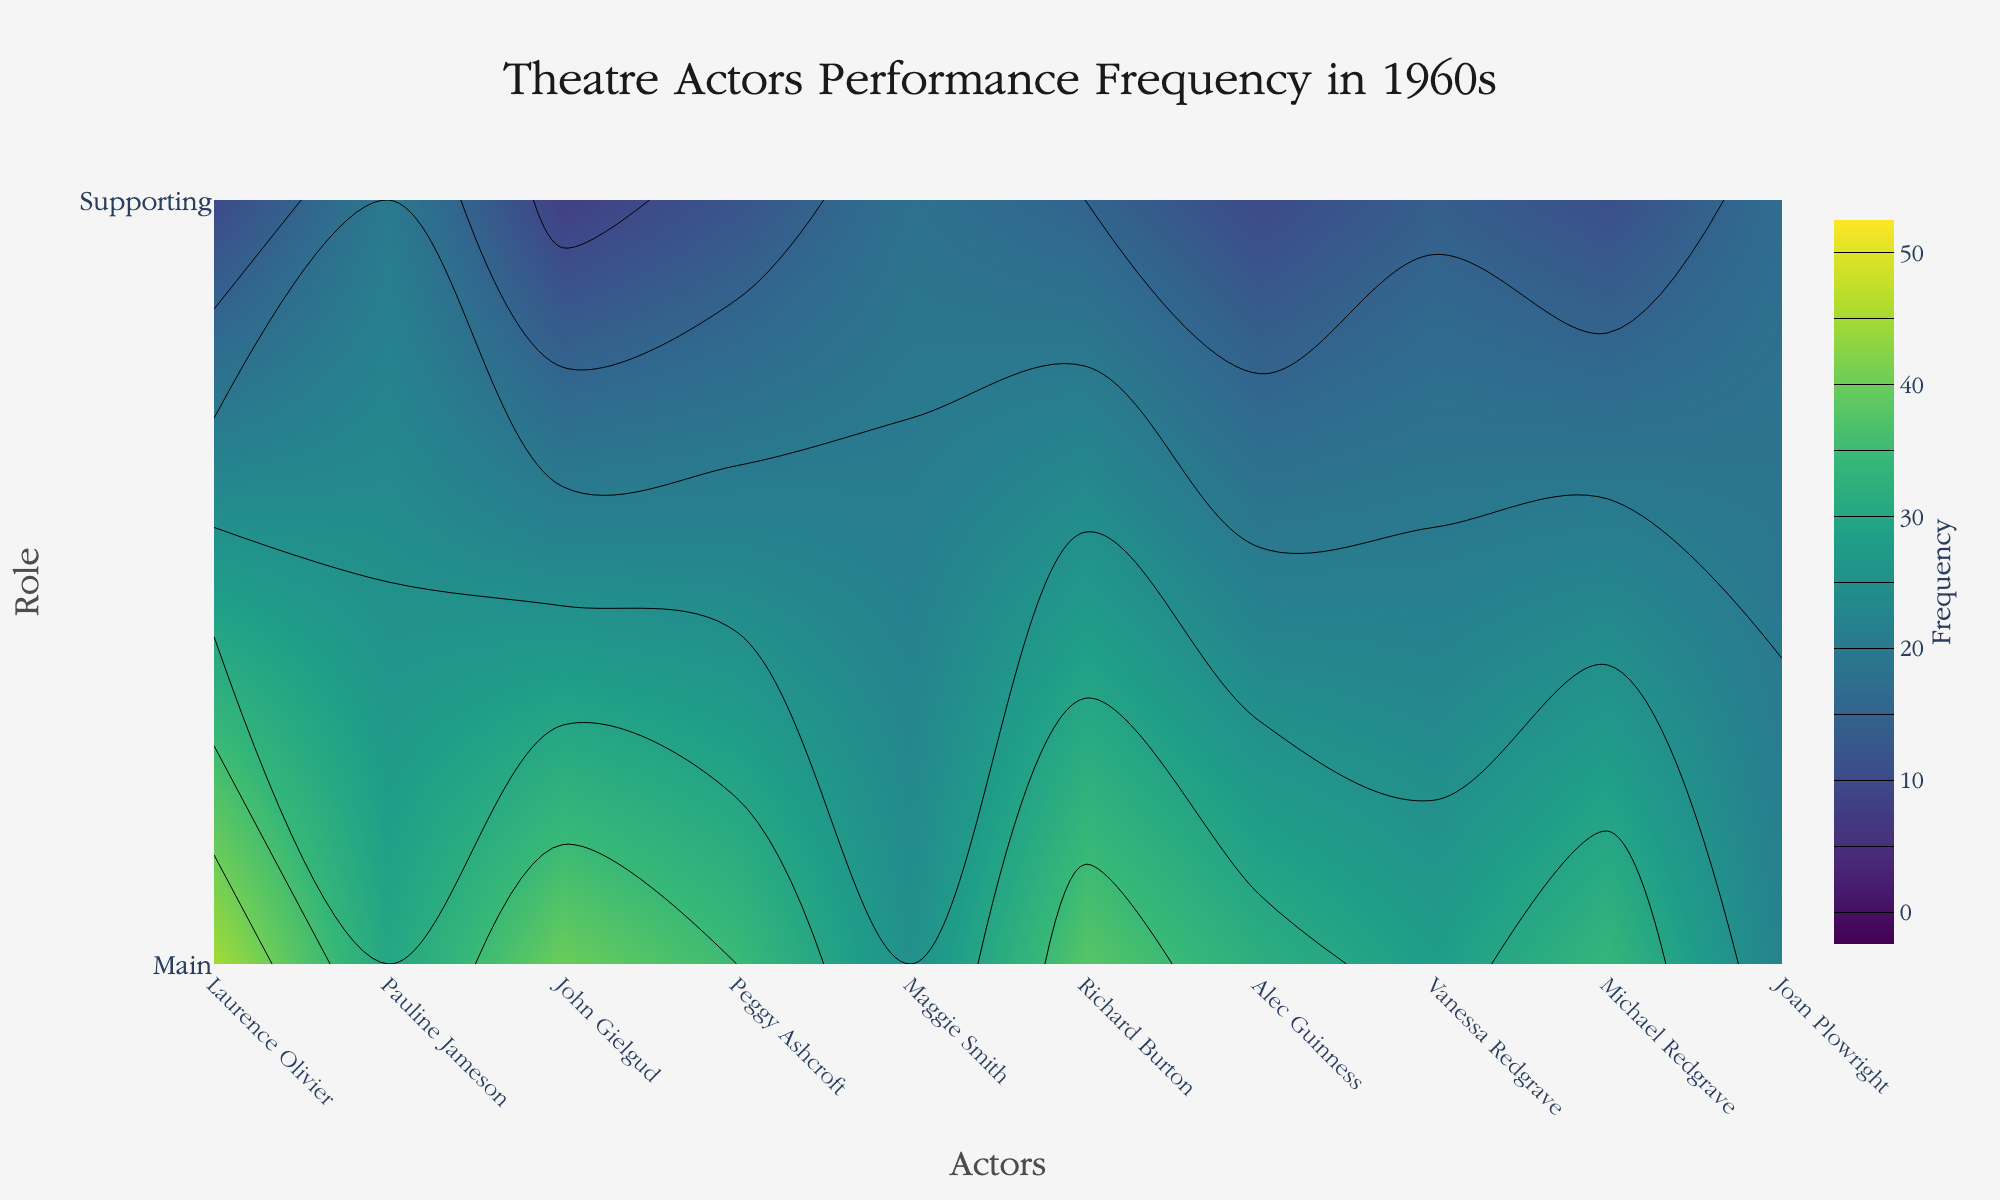What is the title of the figure? The title is placed at the top of the figure and reads "Theatre Actors Performance Frequency in 1960s".
Answer: Theatre Actors Performance Frequency in 1960s Who is the most frequently performing main character on the graph? To find this, look for the highest value in the main roles contour, which corresponds to Laurence Olivier with a frequency of 45 performances.
Answer: Laurence Olivier Compare the frequencies of main and supporting roles for Pauline Jameson. Which is higher? Refer to Pauline Jameson's data points on the chart. Her main role frequency is 30, while her supporting role frequency is 20. The main role frequency is higher.
Answer: Main role Which actor has the smallest difference in the number of performances between main and supporting roles? Calculate the difference in performance frequency for each actor. Joan Plowright has the smallest difference, with 5 performances (22 main, 17 supporting).
Answer: Joan Plowright On average, does John Gielgud perform more in main or supporting roles? Check John Gielgud's performance frequencies: 40 main and 8 supporting. The average is calculated as (40 + 8)/2 = 24 for comparison, but directly comparing 40 against 8 shows that main roles are more frequent.
Answer: Main roles How do the performance frequencies of Laurence Olivier compare to Maggie Smith's? Laurence Olivier's performances are 45 (main) and 10 (supporting), while Maggie Smith's are 25 (main) and 18 (supporting). Olivier performs more frequently in main roles (45 vs. 25) but less in supporting roles (10 vs. 18).
Answer: Laurence Olivier performs more in main roles and less in supporting roles compared to Maggie Smith What is the sum of performances in both roles for Peggy Ashcroft? Peggy Ashcroft's performance frequencies are 35 (main) and 12 (supporting). The sum is 35 + 12 = 47.
Answer: 47 Who has a higher supporting role performance frequency, Vanessa Redgrave or Michael Redgrave? Check their supporting role performance frequencies: Vanessa Redgrave has 14, and Michael Redgrave has 11. Vanessa Redgrave has a higher frequency.
Answer: Vanessa Redgrave In terms of contour levels, which role shows a broader range of frequencies, main or supporting? By observing the contour plot, the "Main" role frequencies vary more widely from around ~20 to 45, while "Supporting" role ranges from ~10 to 20.
Answer: Main 